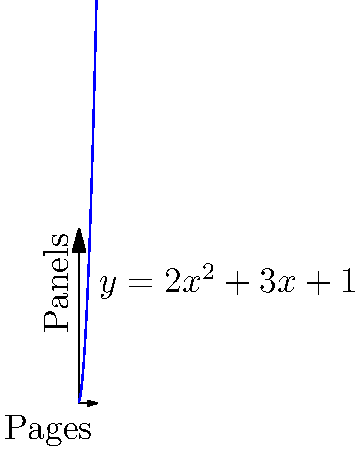Given that the function $y = 2x^2 + 3x + 1$ represents the number of panels ($y$) on a comic book page ($x$), calculate the instantaneous rate of change in panel count on the 5th page. To find the instantaneous rate of change at a specific point, we need to calculate the derivative of the function and evaluate it at the given point.

1. The given function is $y = 2x^2 + 3x + 1$

2. To find the derivative, we use the power rule and constant rule:
   $\frac{dy}{dx} = 4x + 3$

3. We want to find the rate of change at the 5th page, so we substitute $x = 5$:
   $\frac{dy}{dx}|_{x=5} = 4(5) + 3 = 20 + 3 = 23$

4. The result, 23, represents the instantaneous rate of change in panel count on the 5th page.

This means that at the 5th page, the number of panels is increasing at a rate of 23 panels per page.
Answer: 23 panels per page 